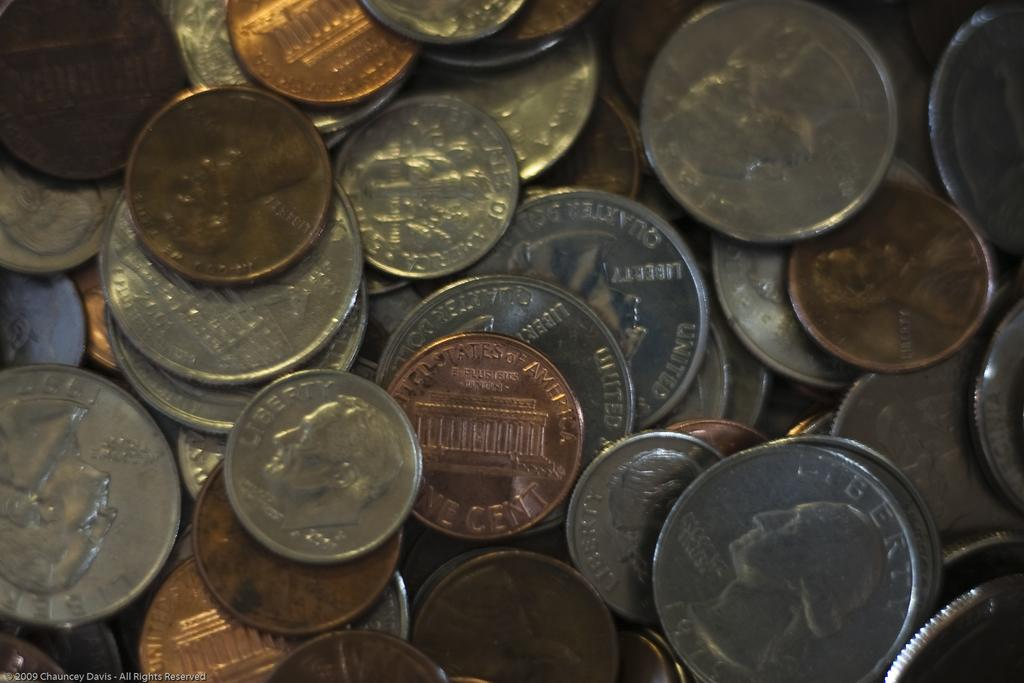<image>
Create a compact narrative representing the image presented. a 2001 dime is laying on the top of a bunch of other change 